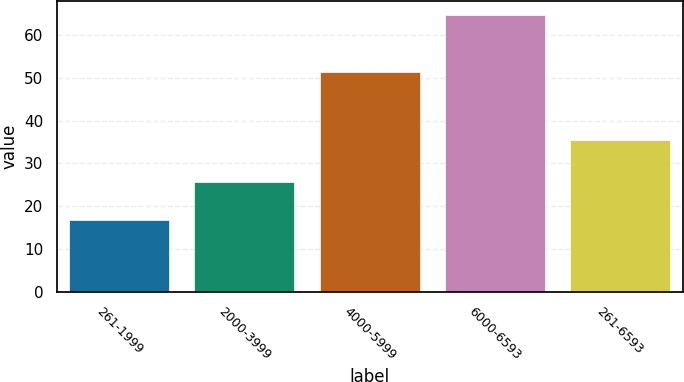Convert chart to OTSL. <chart><loc_0><loc_0><loc_500><loc_500><bar_chart><fcel>261-1999<fcel>2000-3999<fcel>4000-5999<fcel>6000-6593<fcel>261-6593<nl><fcel>16.88<fcel>25.75<fcel>51.28<fcel>64.67<fcel>35.37<nl></chart> 